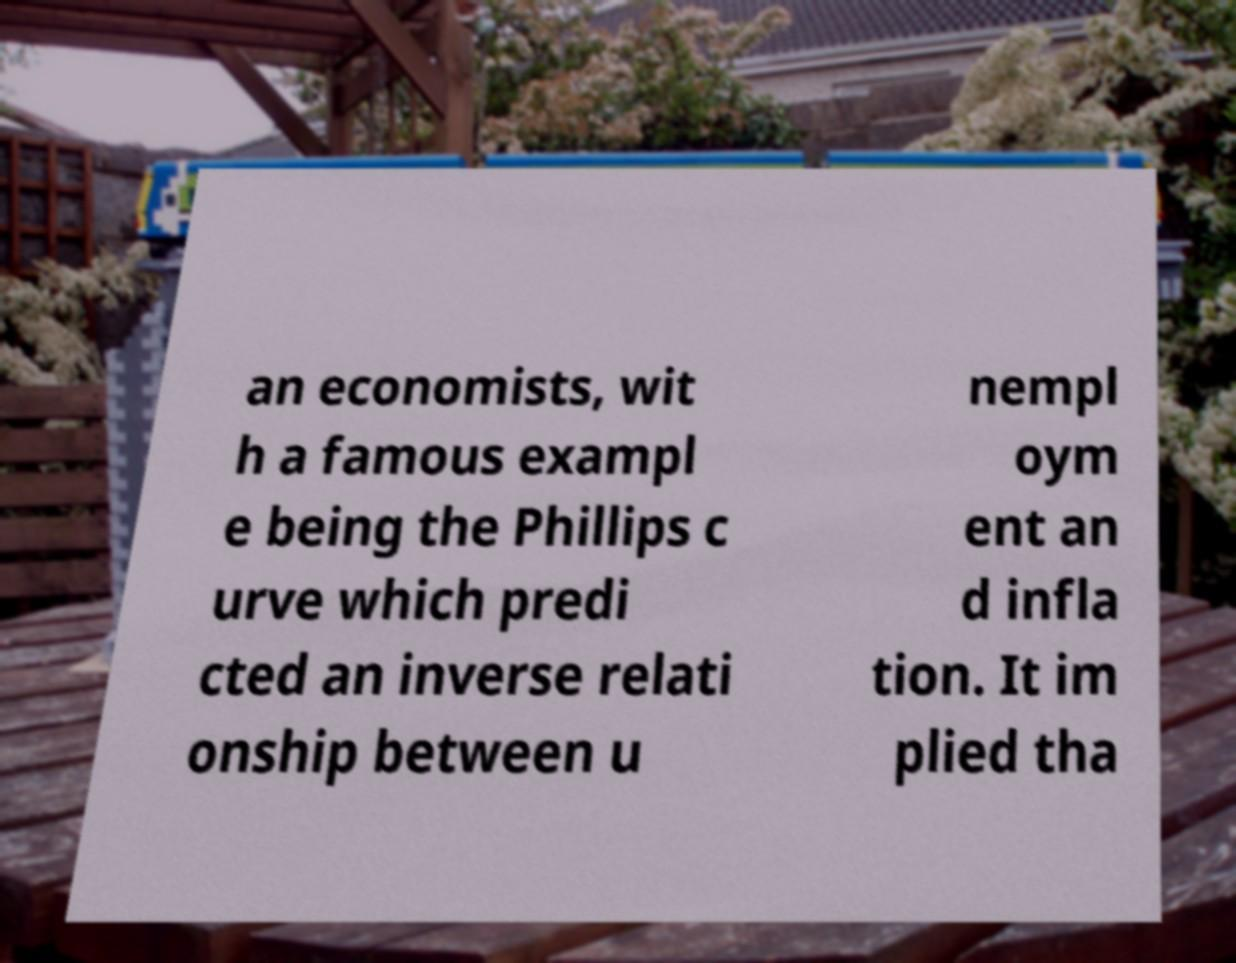I need the written content from this picture converted into text. Can you do that? an economists, wit h a famous exampl e being the Phillips c urve which predi cted an inverse relati onship between u nempl oym ent an d infla tion. It im plied tha 